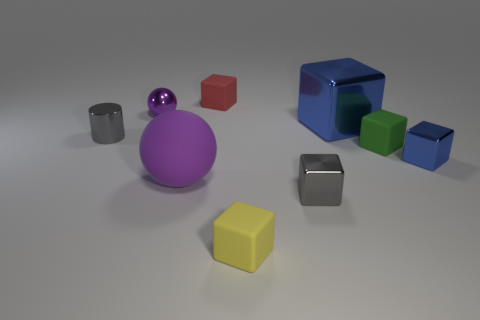Which object appears to be the largest, and can you describe its position relative to the other objects? The largest object in the image is the blue cube. It is positioned to the far right of the image, adjacent to a smaller green cube and behind a small red cube when viewed from the perspective of the camera. Its considerable size makes it stand out against the other smaller objects in the scene. 